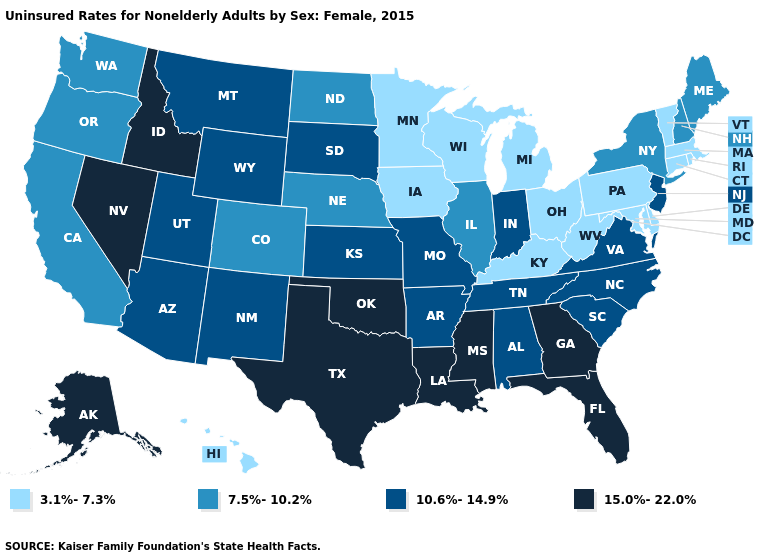What is the value of New York?
Write a very short answer. 7.5%-10.2%. What is the value of Texas?
Concise answer only. 15.0%-22.0%. Among the states that border Delaware , which have the lowest value?
Quick response, please. Maryland, Pennsylvania. What is the lowest value in states that border Wyoming?
Short answer required. 7.5%-10.2%. What is the value of New Hampshire?
Short answer required. 7.5%-10.2%. How many symbols are there in the legend?
Write a very short answer. 4. Name the states that have a value in the range 15.0%-22.0%?
Answer briefly. Alaska, Florida, Georgia, Idaho, Louisiana, Mississippi, Nevada, Oklahoma, Texas. Which states have the lowest value in the USA?
Keep it brief. Connecticut, Delaware, Hawaii, Iowa, Kentucky, Maryland, Massachusetts, Michigan, Minnesota, Ohio, Pennsylvania, Rhode Island, Vermont, West Virginia, Wisconsin. What is the highest value in the USA?
Write a very short answer. 15.0%-22.0%. What is the highest value in the MidWest ?
Give a very brief answer. 10.6%-14.9%. Name the states that have a value in the range 10.6%-14.9%?
Keep it brief. Alabama, Arizona, Arkansas, Indiana, Kansas, Missouri, Montana, New Jersey, New Mexico, North Carolina, South Carolina, South Dakota, Tennessee, Utah, Virginia, Wyoming. Which states have the lowest value in the Northeast?
Be succinct. Connecticut, Massachusetts, Pennsylvania, Rhode Island, Vermont. Among the states that border New Mexico , which have the lowest value?
Concise answer only. Colorado. What is the lowest value in the USA?
Be succinct. 3.1%-7.3%. 